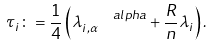Convert formula to latex. <formula><loc_0><loc_0><loc_500><loc_500>\tau _ { i } \colon = \frac { 1 } { 4 } \left ( \lambda _ { i , \alpha } ^ { \ \ \ \ a l p h a } + \frac { R } { n } \lambda _ { i } \right ) .</formula> 